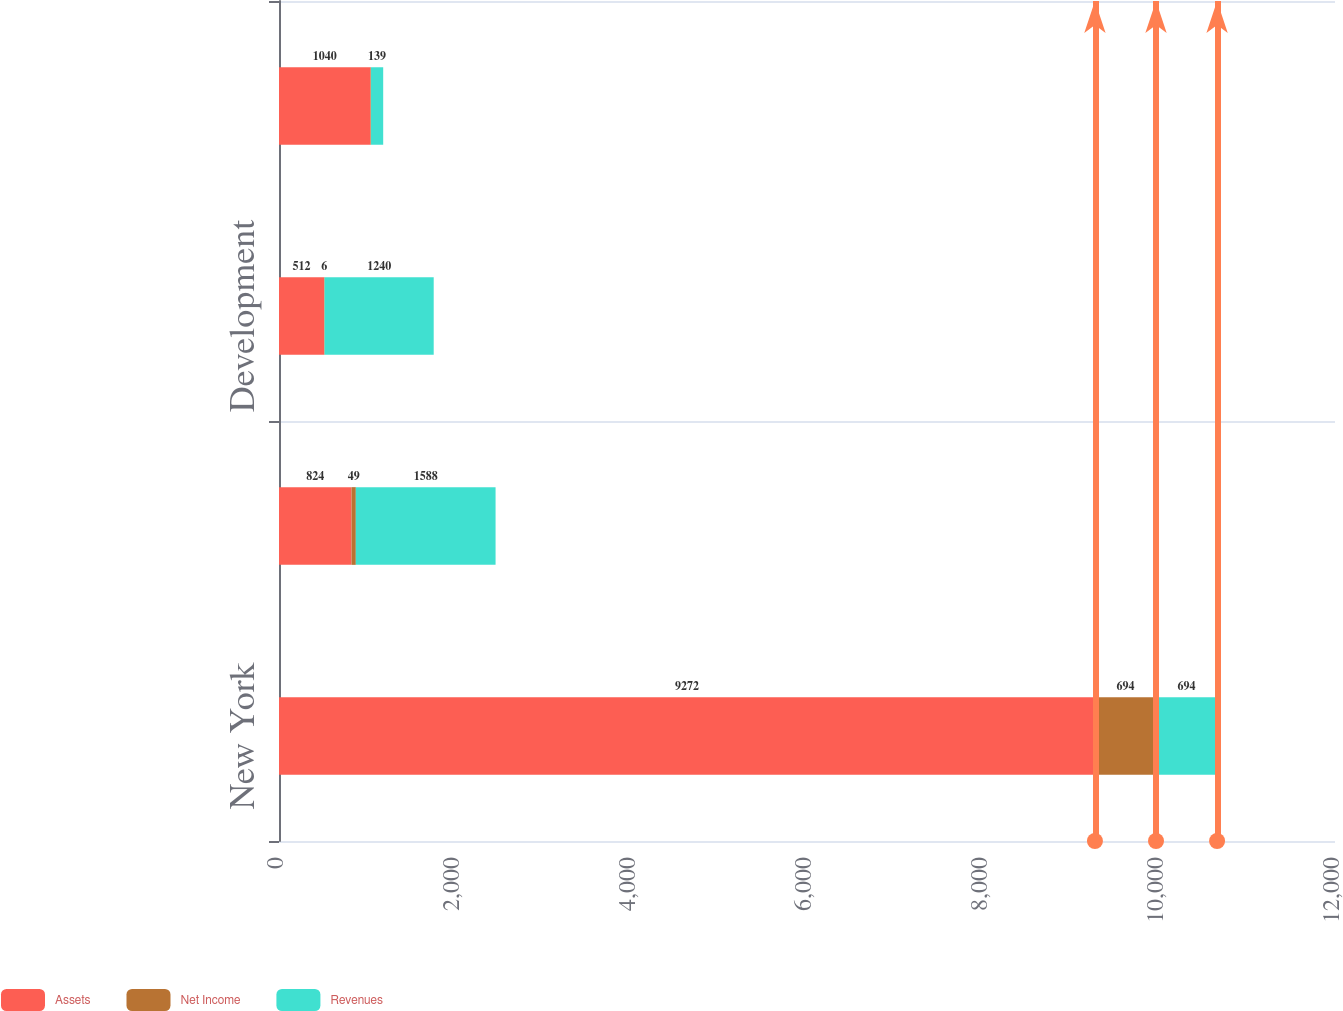Convert chart to OTSL. <chart><loc_0><loc_0><loc_500><loc_500><stacked_bar_chart><ecel><fcel>New York<fcel>O&R<fcel>Development<fcel>Con Edison Solutions<nl><fcel>Assets<fcel>9272<fcel>824<fcel>512<fcel>1040<nl><fcel>Net Income<fcel>694<fcel>49<fcel>6<fcel>5<nl><fcel>Revenues<fcel>694<fcel>1588<fcel>1240<fcel>139<nl></chart> 